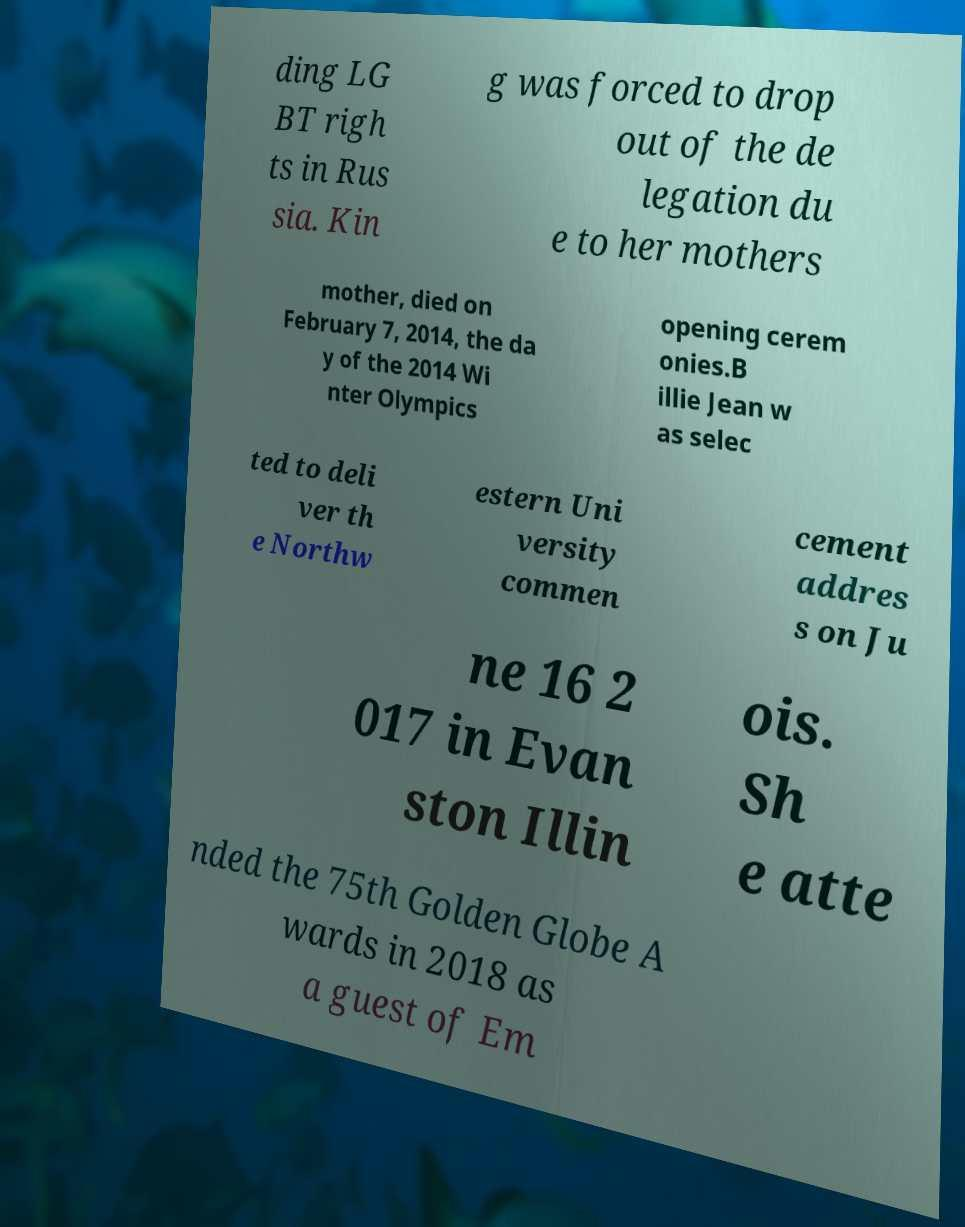There's text embedded in this image that I need extracted. Can you transcribe it verbatim? ding LG BT righ ts in Rus sia. Kin g was forced to drop out of the de legation du e to her mothers mother, died on February 7, 2014, the da y of the 2014 Wi nter Olympics opening cerem onies.B illie Jean w as selec ted to deli ver th e Northw estern Uni versity commen cement addres s on Ju ne 16 2 017 in Evan ston Illin ois. Sh e atte nded the 75th Golden Globe A wards in 2018 as a guest of Em 